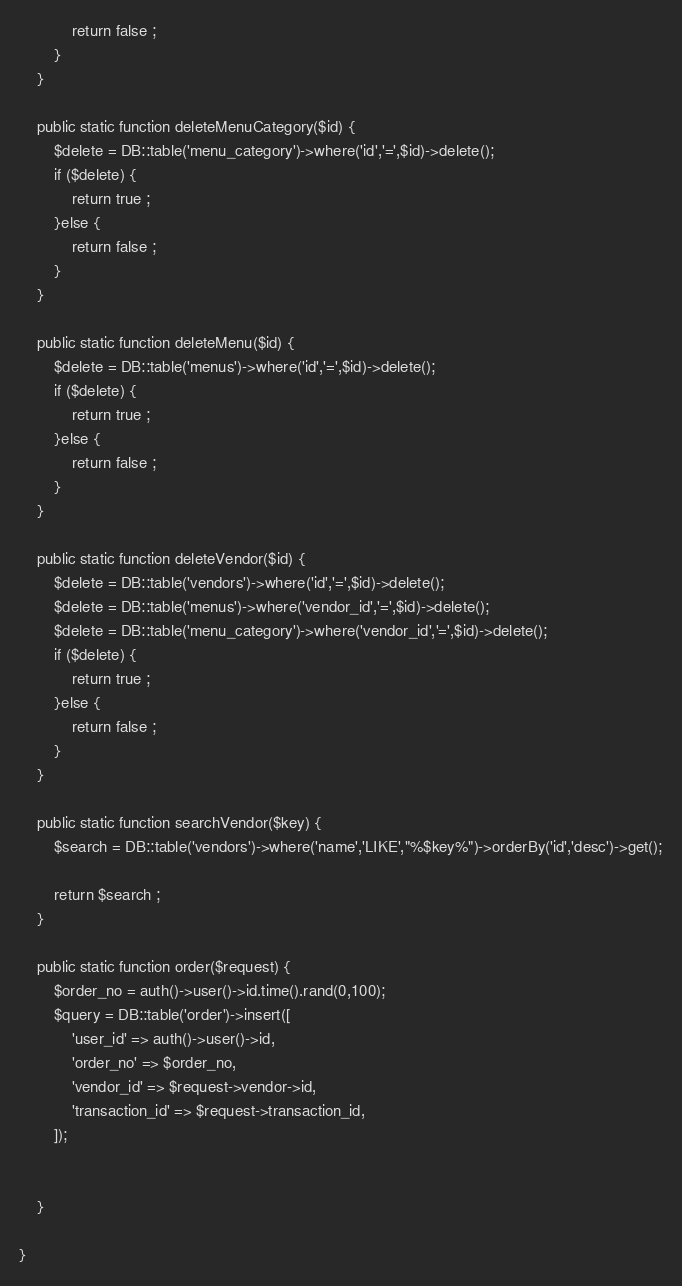<code> <loc_0><loc_0><loc_500><loc_500><_PHP_>            return false ;
        }
    }

    public static function deleteMenuCategory($id) {
        $delete = DB::table('menu_category')->where('id','=',$id)->delete();
        if ($delete) {
            return true ;
        }else {
            return false ;
        }
    }

    public static function deleteMenu($id) {
        $delete = DB::table('menus')->where('id','=',$id)->delete();
        if ($delete) {
            return true ;
        }else {
            return false ;
        }
    }

    public static function deleteVendor($id) {
        $delete = DB::table('vendors')->where('id','=',$id)->delete();
        $delete = DB::table('menus')->where('vendor_id','=',$id)->delete();
        $delete = DB::table('menu_category')->where('vendor_id','=',$id)->delete();
        if ($delete) {
            return true ;
        }else {
            return false ;
        }
    }

    public static function searchVendor($key) {
        $search = DB::table('vendors')->where('name','LIKE',"%$key%")->orderBy('id','desc')->get();

        return $search ;
    }

    public static function order($request) {
        $order_no = auth()->user()->id.time().rand(0,100);
        $query = DB::table('order')->insert([
            'user_id' => auth()->user()->id,
            'order_no' => $order_no,
            'vendor_id' => $request->vendor->id,
            'transaction_id' => $request->transaction_id,
        ]);


    }

}
</code> 